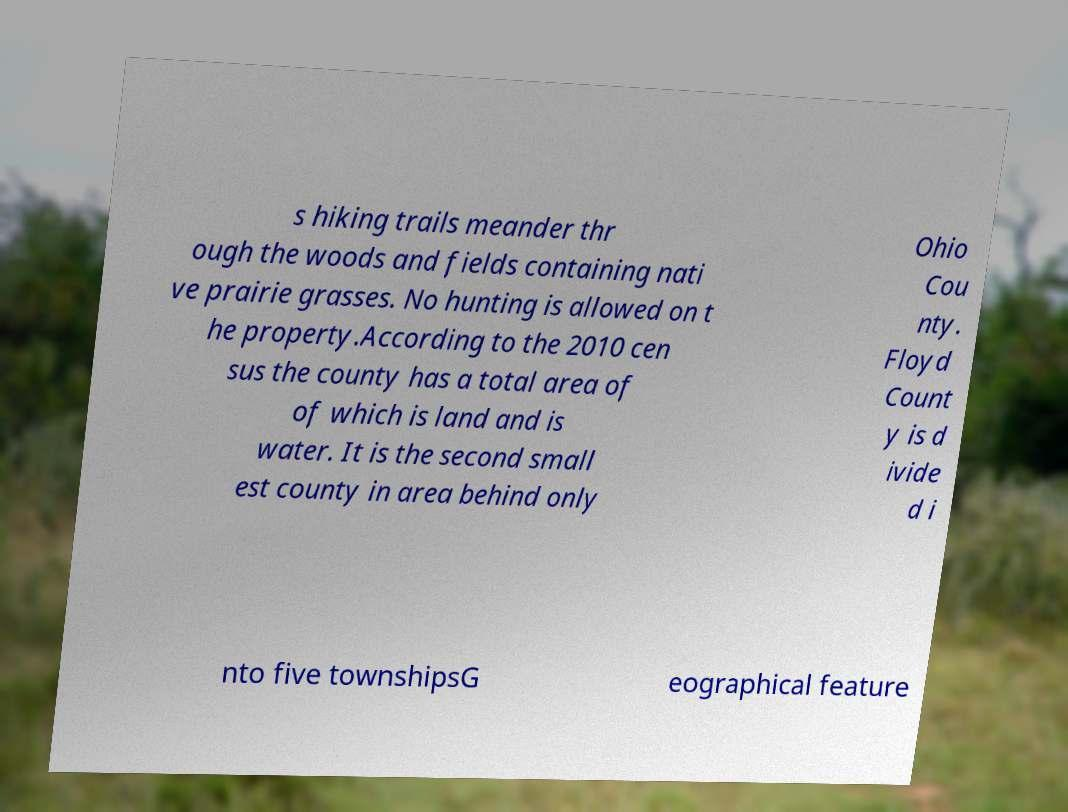What messages or text are displayed in this image? I need them in a readable, typed format. s hiking trails meander thr ough the woods and fields containing nati ve prairie grasses. No hunting is allowed on t he property.According to the 2010 cen sus the county has a total area of of which is land and is water. It is the second small est county in area behind only Ohio Cou nty. Floyd Count y is d ivide d i nto five townshipsG eographical feature 